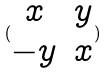<formula> <loc_0><loc_0><loc_500><loc_500>( \begin{matrix} x & y \\ - y & x \end{matrix} )</formula> 